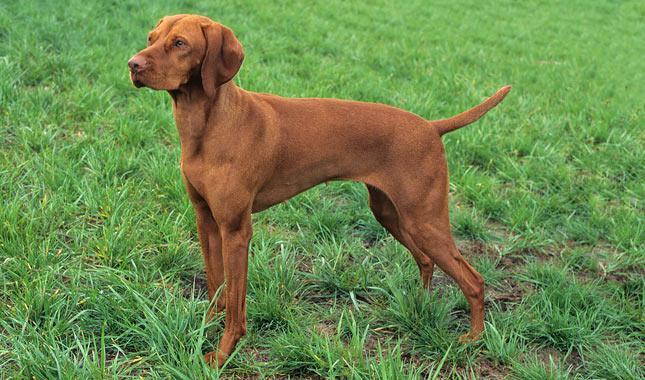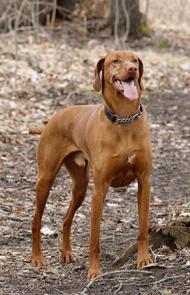The first image is the image on the left, the second image is the image on the right. Evaluate the accuracy of this statement regarding the images: "The dog in each of the images is standing up on all four.". Is it true? Answer yes or no. Yes. 